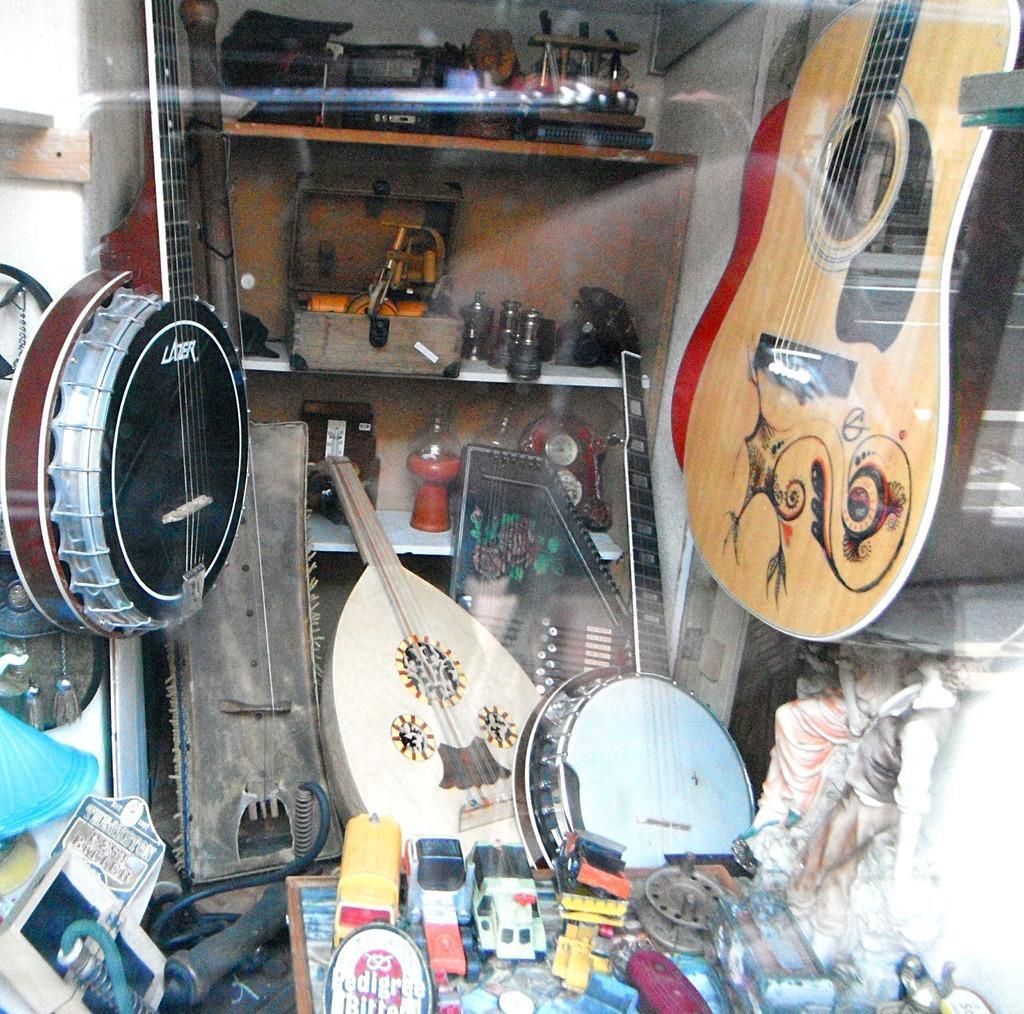Can you describe this image briefly? In this image there are many musical instruments, guitar, banjo, drums. In the background there is a rack with shelves and there are few things in it. In the right side of the image there is a statue. At the bottom of the image there is a table and there are few toys on it. 